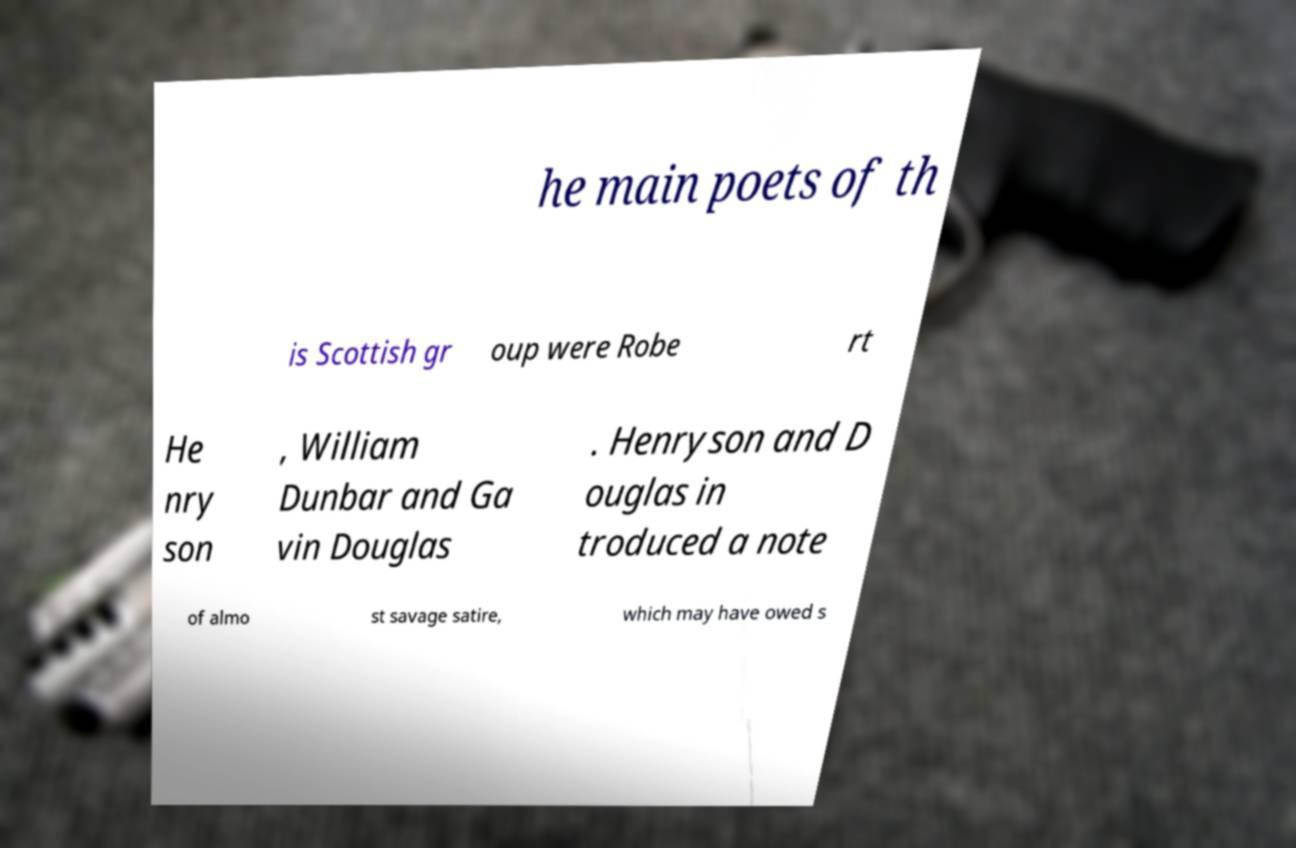Please identify and transcribe the text found in this image. he main poets of th is Scottish gr oup were Robe rt He nry son , William Dunbar and Ga vin Douglas . Henryson and D ouglas in troduced a note of almo st savage satire, which may have owed s 